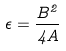<formula> <loc_0><loc_0><loc_500><loc_500>\epsilon = \frac { B ^ { 2 } } { 4 A }</formula> 